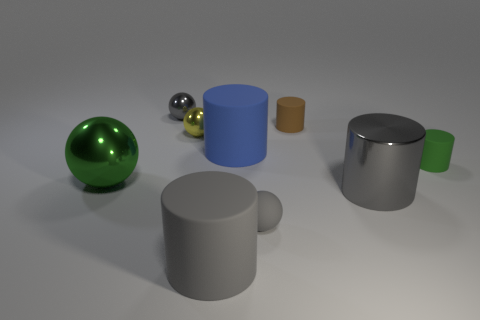There is a gray thing that is both on the left side of the blue rubber cylinder and in front of the big blue object; what material is it?
Provide a succinct answer. Rubber. Is the shape of the yellow shiny object the same as the large green object?
Your answer should be compact. Yes. How many large matte cylinders are behind the green cylinder?
Offer a very short reply. 1. Do the gray shiny thing in front of the blue object and the green shiny object have the same size?
Your answer should be very brief. Yes. What color is the other tiny object that is the same shape as the small brown object?
Give a very brief answer. Green. What is the shape of the big shiny thing in front of the large green ball?
Keep it short and to the point. Cylinder. What number of tiny objects have the same shape as the large blue thing?
Provide a succinct answer. 2. Does the cylinder that is to the right of the metal cylinder have the same color as the big metal thing that is to the left of the tiny brown matte cylinder?
Your response must be concise. Yes. What number of objects are gray rubber cylinders or gray metallic things?
Provide a short and direct response. 3. How many blue things are made of the same material as the tiny green cylinder?
Your answer should be compact. 1. 